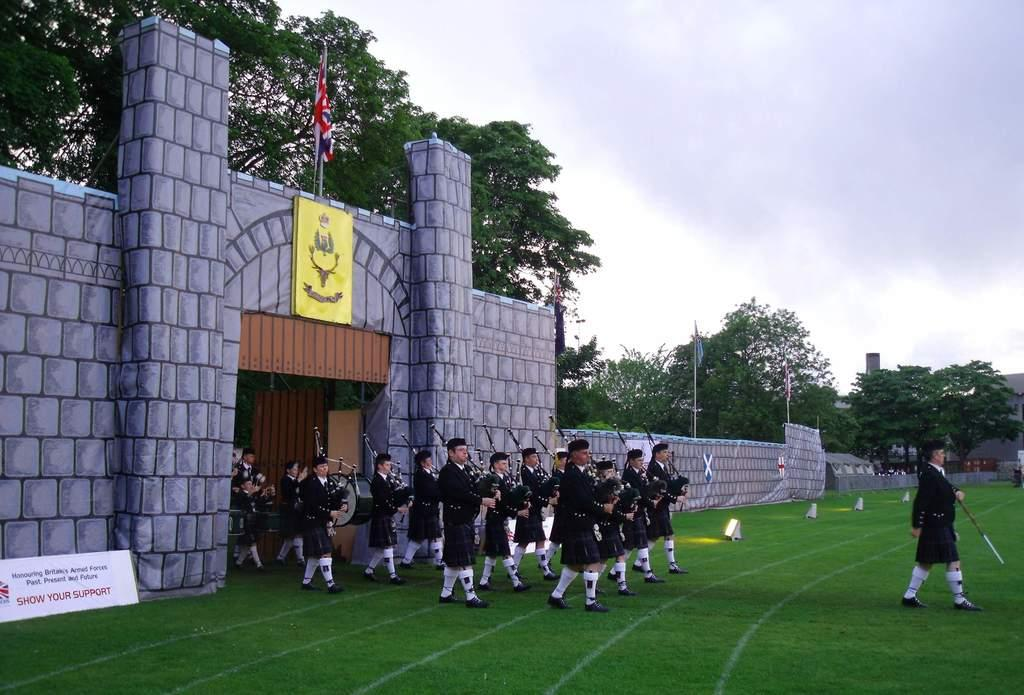<image>
Present a compact description of the photo's key features. A band marchine out onto the field with a sign that says Show Your Support. 